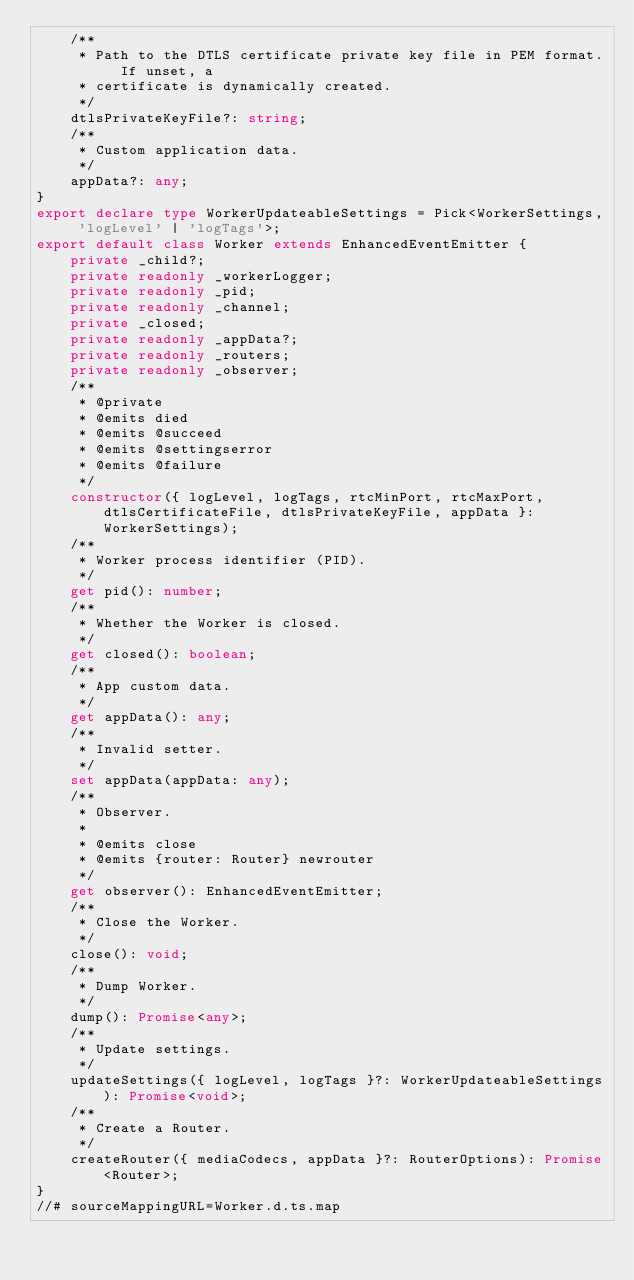Convert code to text. <code><loc_0><loc_0><loc_500><loc_500><_TypeScript_>    /**
     * Path to the DTLS certificate private key file in PEM format. If unset, a
     * certificate is dynamically created.
     */
    dtlsPrivateKeyFile?: string;
    /**
     * Custom application data.
     */
    appData?: any;
}
export declare type WorkerUpdateableSettings = Pick<WorkerSettings, 'logLevel' | 'logTags'>;
export default class Worker extends EnhancedEventEmitter {
    private _child?;
    private readonly _workerLogger;
    private readonly _pid;
    private readonly _channel;
    private _closed;
    private readonly _appData?;
    private readonly _routers;
    private readonly _observer;
    /**
     * @private
     * @emits died
     * @emits @succeed
     * @emits @settingserror
     * @emits @failure
     */
    constructor({ logLevel, logTags, rtcMinPort, rtcMaxPort, dtlsCertificateFile, dtlsPrivateKeyFile, appData }: WorkerSettings);
    /**
     * Worker process identifier (PID).
     */
    get pid(): number;
    /**
     * Whether the Worker is closed.
     */
    get closed(): boolean;
    /**
     * App custom data.
     */
    get appData(): any;
    /**
     * Invalid setter.
     */
    set appData(appData: any);
    /**
     * Observer.
     *
     * @emits close
     * @emits {router: Router} newrouter
     */
    get observer(): EnhancedEventEmitter;
    /**
     * Close the Worker.
     */
    close(): void;
    /**
     * Dump Worker.
     */
    dump(): Promise<any>;
    /**
     * Update settings.
     */
    updateSettings({ logLevel, logTags }?: WorkerUpdateableSettings): Promise<void>;
    /**
     * Create a Router.
     */
    createRouter({ mediaCodecs, appData }?: RouterOptions): Promise<Router>;
}
//# sourceMappingURL=Worker.d.ts.map</code> 